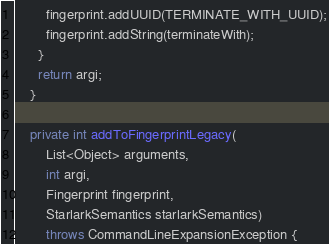Convert code to text. <code><loc_0><loc_0><loc_500><loc_500><_Java_>        fingerprint.addUUID(TERMINATE_WITH_UUID);
        fingerprint.addString(terminateWith);
      }
      return argi;
    }

    private int addToFingerprintLegacy(
        List<Object> arguments,
        int argi,
        Fingerprint fingerprint,
        StarlarkSemantics starlarkSemantics)
        throws CommandLineExpansionException {</code> 